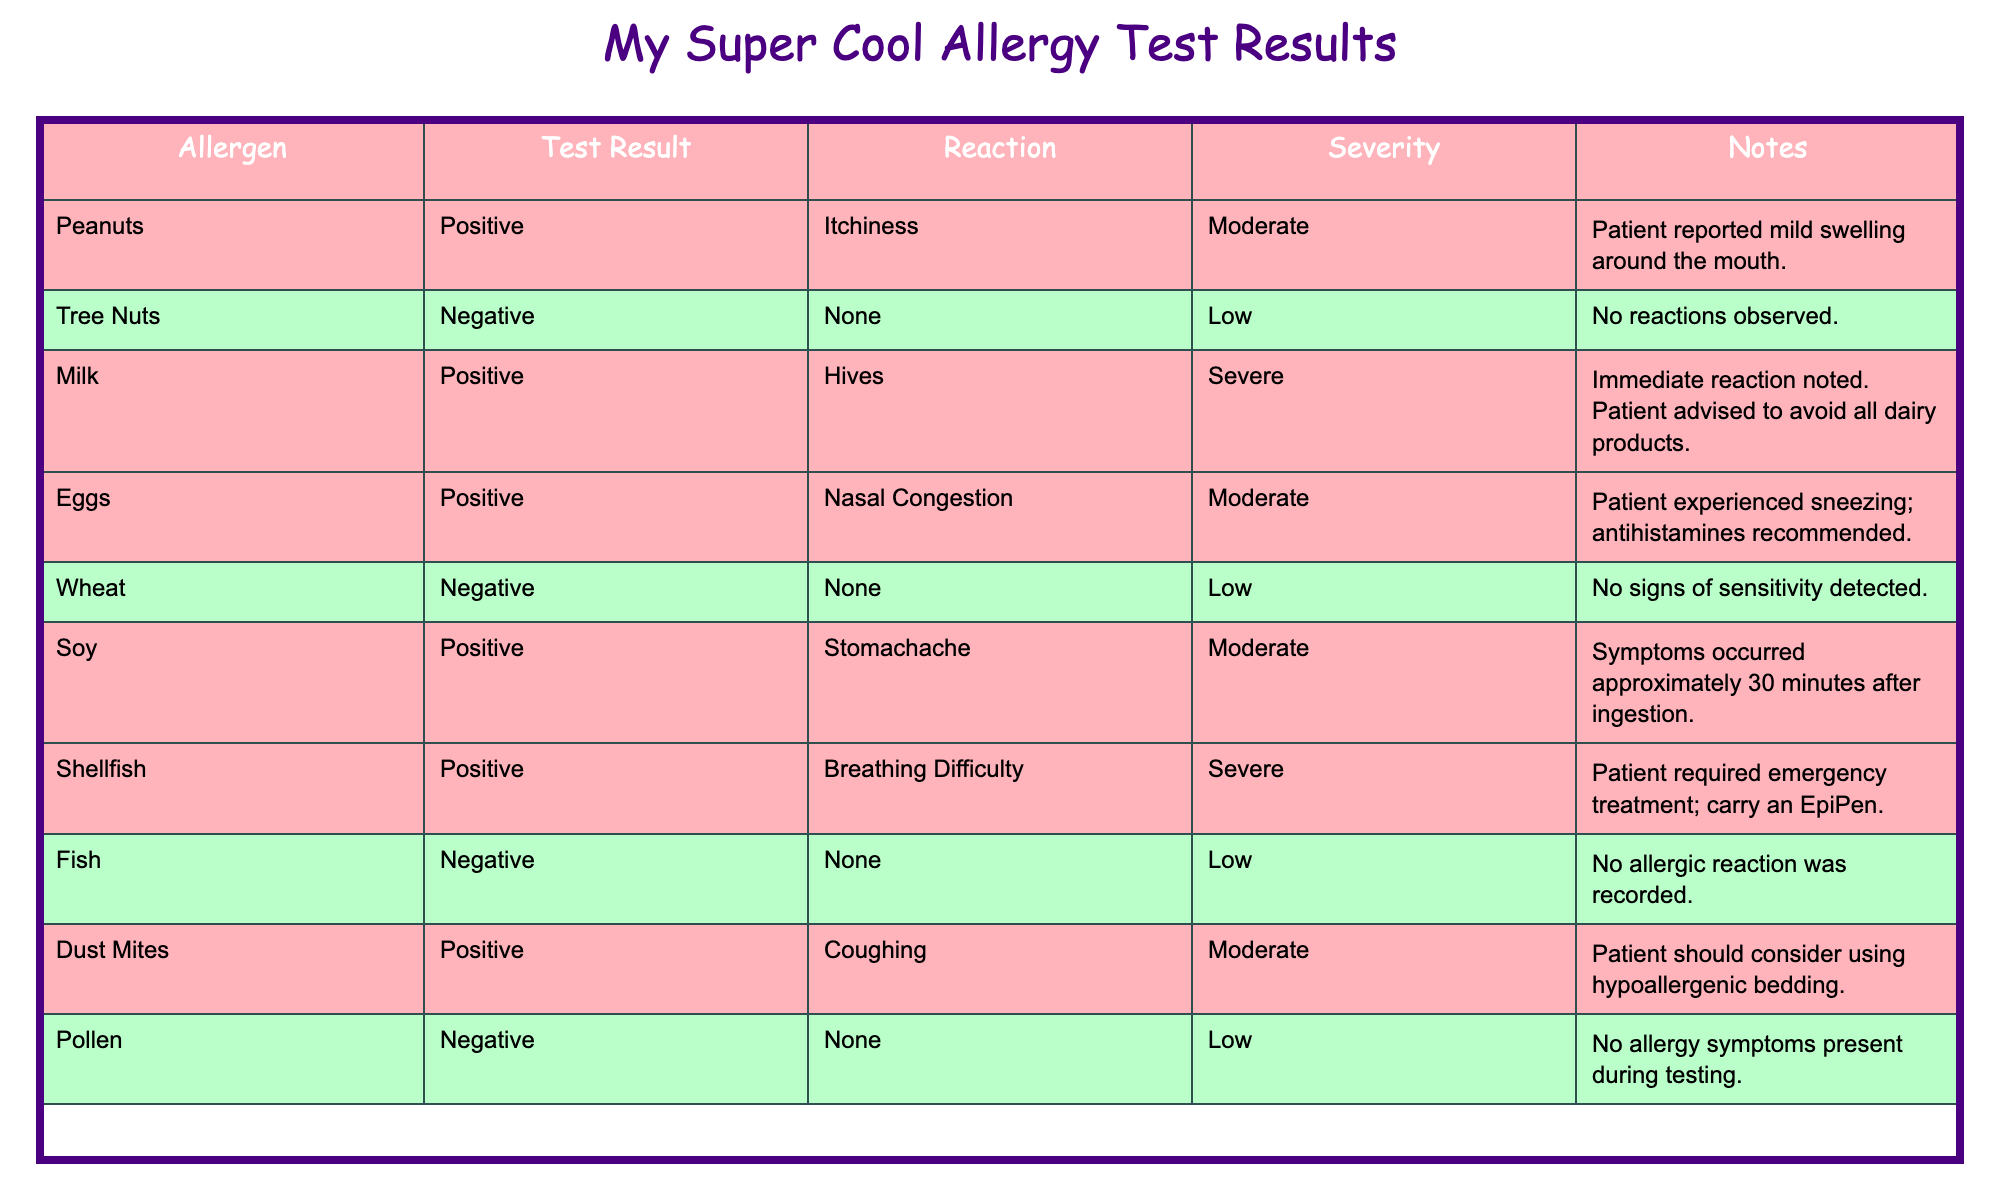What is the test result for Peanuts? The table indicates that the Test Result for Peanuts is "Positive."
Answer: Positive How many allergens had a negative test result? The table lists two allergens, Tree Nuts and Wheat, with a "Negative" test result.
Answer: 2 Which allergen caused severe reactions and what was it? The table shows that Milk and Shellfish both caused severe reactions. Milk resulted in hives, and Shellfish resulted in breathing difficulty.
Answer: Milk and Shellfish What is the most severe reaction recorded? The table indicates that both Milk and Shellfish had the most severe reaction categories, which is "Severe."
Answer: Severe How many allergens caused moderate reactions? By counting the entries for moderate reactions, we see Peanuts, Eggs, Soy, and Dust Mites which totals four allergens causing moderate reactions.
Answer: 4 Is there any allergen that caused a reaction and tested negative? According to the table, all allergens that tested negative (Tree Nuts, Wheat, Pollen, Fish) did not cause any reactions, so the answer is no.
Answer: No What specific reaction was noted for Shellfish? The table states that Shellfish caused "Breathing Difficulty."
Answer: Breathing Difficulty If we only consider allergens that caused a positive test result, how many resulted in hives? Looking through the positive results, only Milk caused hives, which is one occurrence.
Answer: 1 What is the average severity level of reactions caused by allergens that tested positive? The severity levels for positive results are Moderate (3 occurrences), and Severe (2 occurrences). Assigning numerical values (Low=1, Moderate=2, Severe=3), we can calculate: (2*3 + 3*2) / 5 = (6 + 6)/5 = 12/5 = 2.4 which shows an average severity of Moderate leaning towards Severe.
Answer: 2.4 